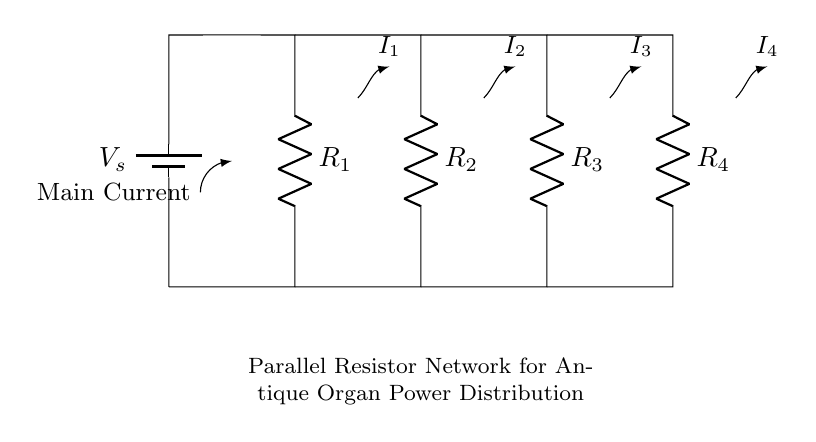What is the source voltage in this circuit? The source voltage is denoted as V_s, which is labeled near the battery at the top left corner of the diagram.
Answer: V_s How many resistors are present in the circuit? The circuit diagram clearly shows four resistors, labeled R_1, R_2, R_3, and R_4. These can be counted in the representation from left to right.
Answer: 4 What type of circuit is represented here? The circuit is a parallel resistor network, as indicated by the connections that allow current to divide through multiple paths.
Answer: Parallel What does the arrow direction of the main current indicate? The arrow pointing towards the bottom of the circuit diagram indicates the direction of the main current flowing from the power source through the resistors.
Answer: Downward Which resistor has the highest current flowing through it? The essence of a current divider shows that the current through each resistor depends on their resistance values. Assuming all resistors have the same value, the current will be equally divided which means none holds the highest.
Answer: Equal current (if resistors are identical) What is the individual current through each resistor if they are of equal resistance? Based on the concept of a current divider, if all resistors have the same resistance, the total current is divided equally among them, giving the individual current as the total current divided by the number of resistors.
Answer: Total current / 4 What happens to total current when a competing resistor is added? Adding a resistor in parallel decreases the total resistance of the network, thus increasing the total current supplied by the source due to Ohm's law.
Answer: Increases total current 